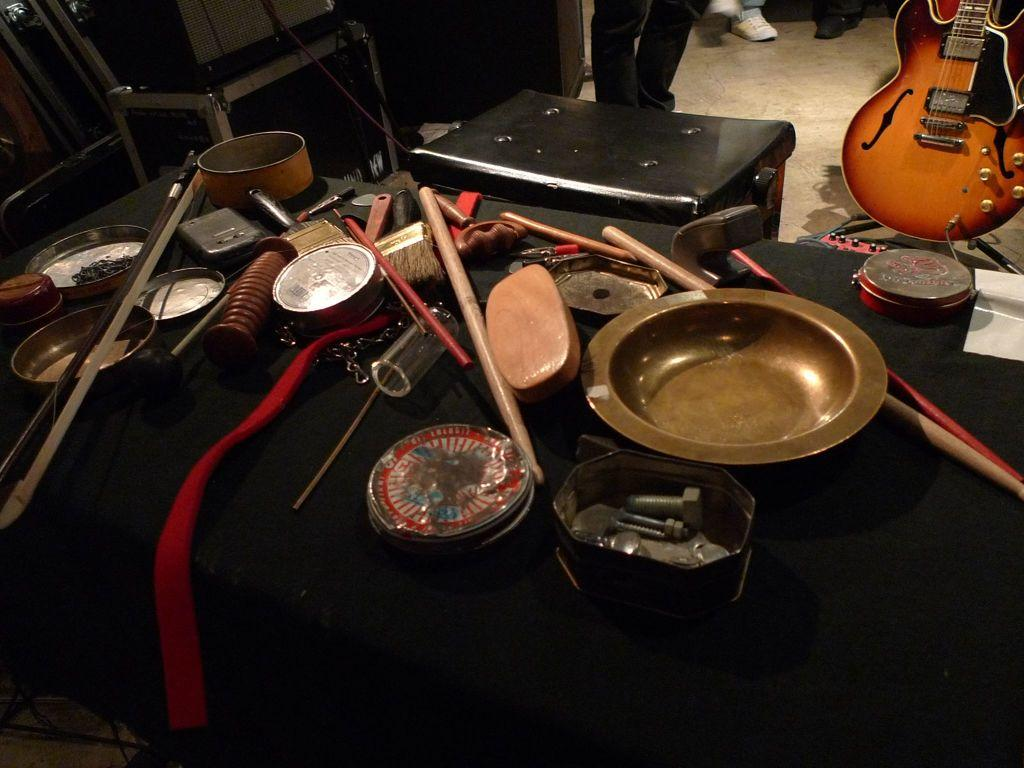What is the main piece of furniture in the image? There is a table in the image. What can be found on the table? There are objects on the table. What type of hill can be seen in the background of the image? There is no hill present in the image; it only features a table with objects on it. 